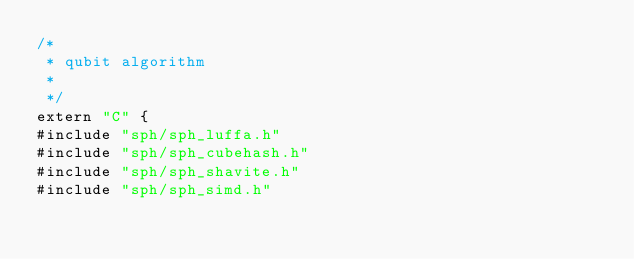<code> <loc_0><loc_0><loc_500><loc_500><_Cuda_>/*
 * qubit algorithm
 *
 */
extern "C" {
#include "sph/sph_luffa.h"
#include "sph/sph_cubehash.h"
#include "sph/sph_shavite.h"
#include "sph/sph_simd.h"</code> 